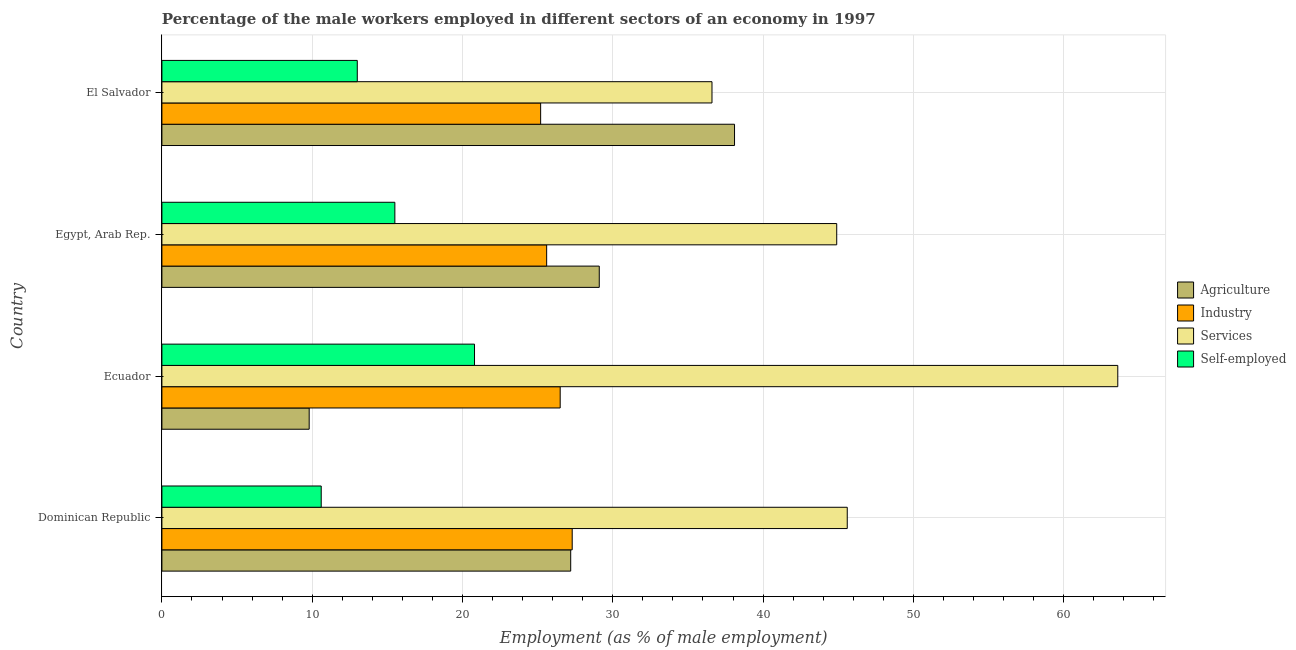How many groups of bars are there?
Provide a succinct answer. 4. Are the number of bars per tick equal to the number of legend labels?
Keep it short and to the point. Yes. Are the number of bars on each tick of the Y-axis equal?
Your answer should be compact. Yes. How many bars are there on the 4th tick from the top?
Ensure brevity in your answer.  4. How many bars are there on the 4th tick from the bottom?
Make the answer very short. 4. What is the label of the 1st group of bars from the top?
Give a very brief answer. El Salvador. What is the percentage of male workers in industry in Ecuador?
Keep it short and to the point. 26.5. Across all countries, what is the maximum percentage of male workers in services?
Offer a very short reply. 63.6. Across all countries, what is the minimum percentage of male workers in industry?
Your answer should be compact. 25.2. In which country was the percentage of male workers in services maximum?
Give a very brief answer. Ecuador. In which country was the percentage of male workers in agriculture minimum?
Ensure brevity in your answer.  Ecuador. What is the total percentage of male workers in agriculture in the graph?
Your answer should be very brief. 104.2. What is the difference between the percentage of male workers in agriculture in Dominican Republic and the percentage of male workers in industry in Egypt, Arab Rep.?
Your answer should be very brief. 1.6. What is the average percentage of self employed male workers per country?
Ensure brevity in your answer.  14.97. What is the difference between the percentage of male workers in agriculture and percentage of male workers in industry in Egypt, Arab Rep.?
Give a very brief answer. 3.5. What is the ratio of the percentage of self employed male workers in Ecuador to that in El Salvador?
Ensure brevity in your answer.  1.6. Is the percentage of male workers in agriculture in Dominican Republic less than that in Ecuador?
Offer a very short reply. No. Is the difference between the percentage of male workers in industry in Ecuador and El Salvador greater than the difference between the percentage of male workers in services in Ecuador and El Salvador?
Your response must be concise. No. What is the difference between the highest and the second highest percentage of male workers in agriculture?
Offer a terse response. 9. What is the difference between the highest and the lowest percentage of male workers in industry?
Make the answer very short. 2.1. Is it the case that in every country, the sum of the percentage of male workers in services and percentage of self employed male workers is greater than the sum of percentage of male workers in agriculture and percentage of male workers in industry?
Offer a terse response. No. What does the 2nd bar from the top in El Salvador represents?
Provide a short and direct response. Services. What does the 1st bar from the bottom in Ecuador represents?
Ensure brevity in your answer.  Agriculture. How many countries are there in the graph?
Offer a terse response. 4. What is the difference between two consecutive major ticks on the X-axis?
Your answer should be very brief. 10. How many legend labels are there?
Your answer should be compact. 4. How are the legend labels stacked?
Keep it short and to the point. Vertical. What is the title of the graph?
Your answer should be very brief. Percentage of the male workers employed in different sectors of an economy in 1997. Does "Gender equality" appear as one of the legend labels in the graph?
Your answer should be compact. No. What is the label or title of the X-axis?
Offer a very short reply. Employment (as % of male employment). What is the Employment (as % of male employment) in Agriculture in Dominican Republic?
Offer a terse response. 27.2. What is the Employment (as % of male employment) of Industry in Dominican Republic?
Provide a succinct answer. 27.3. What is the Employment (as % of male employment) in Services in Dominican Republic?
Ensure brevity in your answer.  45.6. What is the Employment (as % of male employment) in Self-employed in Dominican Republic?
Provide a succinct answer. 10.6. What is the Employment (as % of male employment) in Agriculture in Ecuador?
Keep it short and to the point. 9.8. What is the Employment (as % of male employment) of Industry in Ecuador?
Provide a short and direct response. 26.5. What is the Employment (as % of male employment) in Services in Ecuador?
Ensure brevity in your answer.  63.6. What is the Employment (as % of male employment) in Self-employed in Ecuador?
Offer a terse response. 20.8. What is the Employment (as % of male employment) of Agriculture in Egypt, Arab Rep.?
Provide a short and direct response. 29.1. What is the Employment (as % of male employment) of Industry in Egypt, Arab Rep.?
Your answer should be very brief. 25.6. What is the Employment (as % of male employment) in Services in Egypt, Arab Rep.?
Provide a succinct answer. 44.9. What is the Employment (as % of male employment) of Self-employed in Egypt, Arab Rep.?
Provide a succinct answer. 15.5. What is the Employment (as % of male employment) in Agriculture in El Salvador?
Your answer should be compact. 38.1. What is the Employment (as % of male employment) of Industry in El Salvador?
Your response must be concise. 25.2. What is the Employment (as % of male employment) in Services in El Salvador?
Make the answer very short. 36.6. Across all countries, what is the maximum Employment (as % of male employment) in Agriculture?
Offer a terse response. 38.1. Across all countries, what is the maximum Employment (as % of male employment) in Industry?
Your answer should be very brief. 27.3. Across all countries, what is the maximum Employment (as % of male employment) of Services?
Provide a succinct answer. 63.6. Across all countries, what is the maximum Employment (as % of male employment) of Self-employed?
Give a very brief answer. 20.8. Across all countries, what is the minimum Employment (as % of male employment) in Agriculture?
Offer a terse response. 9.8. Across all countries, what is the minimum Employment (as % of male employment) of Industry?
Make the answer very short. 25.2. Across all countries, what is the minimum Employment (as % of male employment) of Services?
Your response must be concise. 36.6. Across all countries, what is the minimum Employment (as % of male employment) in Self-employed?
Your answer should be very brief. 10.6. What is the total Employment (as % of male employment) in Agriculture in the graph?
Your response must be concise. 104.2. What is the total Employment (as % of male employment) in Industry in the graph?
Offer a very short reply. 104.6. What is the total Employment (as % of male employment) of Services in the graph?
Offer a terse response. 190.7. What is the total Employment (as % of male employment) in Self-employed in the graph?
Your response must be concise. 59.9. What is the difference between the Employment (as % of male employment) in Industry in Dominican Republic and that in Ecuador?
Ensure brevity in your answer.  0.8. What is the difference between the Employment (as % of male employment) in Self-employed in Dominican Republic and that in Ecuador?
Make the answer very short. -10.2. What is the difference between the Employment (as % of male employment) of Agriculture in Dominican Republic and that in Egypt, Arab Rep.?
Offer a terse response. -1.9. What is the difference between the Employment (as % of male employment) in Services in Dominican Republic and that in Egypt, Arab Rep.?
Offer a terse response. 0.7. What is the difference between the Employment (as % of male employment) of Self-employed in Dominican Republic and that in Egypt, Arab Rep.?
Your answer should be compact. -4.9. What is the difference between the Employment (as % of male employment) of Agriculture in Dominican Republic and that in El Salvador?
Keep it short and to the point. -10.9. What is the difference between the Employment (as % of male employment) of Industry in Dominican Republic and that in El Salvador?
Keep it short and to the point. 2.1. What is the difference between the Employment (as % of male employment) of Services in Dominican Republic and that in El Salvador?
Ensure brevity in your answer.  9. What is the difference between the Employment (as % of male employment) of Agriculture in Ecuador and that in Egypt, Arab Rep.?
Offer a very short reply. -19.3. What is the difference between the Employment (as % of male employment) of Services in Ecuador and that in Egypt, Arab Rep.?
Keep it short and to the point. 18.7. What is the difference between the Employment (as % of male employment) of Agriculture in Ecuador and that in El Salvador?
Your response must be concise. -28.3. What is the difference between the Employment (as % of male employment) of Industry in Ecuador and that in El Salvador?
Provide a succinct answer. 1.3. What is the difference between the Employment (as % of male employment) in Self-employed in Ecuador and that in El Salvador?
Offer a terse response. 7.8. What is the difference between the Employment (as % of male employment) of Agriculture in Egypt, Arab Rep. and that in El Salvador?
Keep it short and to the point. -9. What is the difference between the Employment (as % of male employment) of Services in Egypt, Arab Rep. and that in El Salvador?
Make the answer very short. 8.3. What is the difference between the Employment (as % of male employment) in Self-employed in Egypt, Arab Rep. and that in El Salvador?
Ensure brevity in your answer.  2.5. What is the difference between the Employment (as % of male employment) of Agriculture in Dominican Republic and the Employment (as % of male employment) of Services in Ecuador?
Ensure brevity in your answer.  -36.4. What is the difference between the Employment (as % of male employment) of Industry in Dominican Republic and the Employment (as % of male employment) of Services in Ecuador?
Your response must be concise. -36.3. What is the difference between the Employment (as % of male employment) in Services in Dominican Republic and the Employment (as % of male employment) in Self-employed in Ecuador?
Your response must be concise. 24.8. What is the difference between the Employment (as % of male employment) of Agriculture in Dominican Republic and the Employment (as % of male employment) of Services in Egypt, Arab Rep.?
Your response must be concise. -17.7. What is the difference between the Employment (as % of male employment) of Industry in Dominican Republic and the Employment (as % of male employment) of Services in Egypt, Arab Rep.?
Keep it short and to the point. -17.6. What is the difference between the Employment (as % of male employment) of Services in Dominican Republic and the Employment (as % of male employment) of Self-employed in Egypt, Arab Rep.?
Make the answer very short. 30.1. What is the difference between the Employment (as % of male employment) of Agriculture in Dominican Republic and the Employment (as % of male employment) of Services in El Salvador?
Offer a terse response. -9.4. What is the difference between the Employment (as % of male employment) in Agriculture in Dominican Republic and the Employment (as % of male employment) in Self-employed in El Salvador?
Make the answer very short. 14.2. What is the difference between the Employment (as % of male employment) in Services in Dominican Republic and the Employment (as % of male employment) in Self-employed in El Salvador?
Offer a terse response. 32.6. What is the difference between the Employment (as % of male employment) of Agriculture in Ecuador and the Employment (as % of male employment) of Industry in Egypt, Arab Rep.?
Your answer should be very brief. -15.8. What is the difference between the Employment (as % of male employment) of Agriculture in Ecuador and the Employment (as % of male employment) of Services in Egypt, Arab Rep.?
Keep it short and to the point. -35.1. What is the difference between the Employment (as % of male employment) of Agriculture in Ecuador and the Employment (as % of male employment) of Self-employed in Egypt, Arab Rep.?
Ensure brevity in your answer.  -5.7. What is the difference between the Employment (as % of male employment) of Industry in Ecuador and the Employment (as % of male employment) of Services in Egypt, Arab Rep.?
Your answer should be compact. -18.4. What is the difference between the Employment (as % of male employment) in Industry in Ecuador and the Employment (as % of male employment) in Self-employed in Egypt, Arab Rep.?
Your answer should be very brief. 11. What is the difference between the Employment (as % of male employment) of Services in Ecuador and the Employment (as % of male employment) of Self-employed in Egypt, Arab Rep.?
Your answer should be compact. 48.1. What is the difference between the Employment (as % of male employment) of Agriculture in Ecuador and the Employment (as % of male employment) of Industry in El Salvador?
Keep it short and to the point. -15.4. What is the difference between the Employment (as % of male employment) of Agriculture in Ecuador and the Employment (as % of male employment) of Services in El Salvador?
Give a very brief answer. -26.8. What is the difference between the Employment (as % of male employment) of Industry in Ecuador and the Employment (as % of male employment) of Services in El Salvador?
Your answer should be very brief. -10.1. What is the difference between the Employment (as % of male employment) of Services in Ecuador and the Employment (as % of male employment) of Self-employed in El Salvador?
Give a very brief answer. 50.6. What is the difference between the Employment (as % of male employment) of Agriculture in Egypt, Arab Rep. and the Employment (as % of male employment) of Services in El Salvador?
Ensure brevity in your answer.  -7.5. What is the difference between the Employment (as % of male employment) in Agriculture in Egypt, Arab Rep. and the Employment (as % of male employment) in Self-employed in El Salvador?
Make the answer very short. 16.1. What is the difference between the Employment (as % of male employment) of Industry in Egypt, Arab Rep. and the Employment (as % of male employment) of Services in El Salvador?
Keep it short and to the point. -11. What is the difference between the Employment (as % of male employment) of Industry in Egypt, Arab Rep. and the Employment (as % of male employment) of Self-employed in El Salvador?
Your response must be concise. 12.6. What is the difference between the Employment (as % of male employment) in Services in Egypt, Arab Rep. and the Employment (as % of male employment) in Self-employed in El Salvador?
Your answer should be very brief. 31.9. What is the average Employment (as % of male employment) of Agriculture per country?
Offer a terse response. 26.05. What is the average Employment (as % of male employment) in Industry per country?
Ensure brevity in your answer.  26.15. What is the average Employment (as % of male employment) in Services per country?
Your answer should be compact. 47.67. What is the average Employment (as % of male employment) of Self-employed per country?
Offer a very short reply. 14.97. What is the difference between the Employment (as % of male employment) in Agriculture and Employment (as % of male employment) in Services in Dominican Republic?
Your answer should be compact. -18.4. What is the difference between the Employment (as % of male employment) in Industry and Employment (as % of male employment) in Services in Dominican Republic?
Your answer should be compact. -18.3. What is the difference between the Employment (as % of male employment) of Industry and Employment (as % of male employment) of Self-employed in Dominican Republic?
Ensure brevity in your answer.  16.7. What is the difference between the Employment (as % of male employment) in Agriculture and Employment (as % of male employment) in Industry in Ecuador?
Your answer should be compact. -16.7. What is the difference between the Employment (as % of male employment) of Agriculture and Employment (as % of male employment) of Services in Ecuador?
Give a very brief answer. -53.8. What is the difference between the Employment (as % of male employment) of Industry and Employment (as % of male employment) of Services in Ecuador?
Give a very brief answer. -37.1. What is the difference between the Employment (as % of male employment) in Services and Employment (as % of male employment) in Self-employed in Ecuador?
Your response must be concise. 42.8. What is the difference between the Employment (as % of male employment) in Agriculture and Employment (as % of male employment) in Services in Egypt, Arab Rep.?
Offer a terse response. -15.8. What is the difference between the Employment (as % of male employment) in Industry and Employment (as % of male employment) in Services in Egypt, Arab Rep.?
Provide a succinct answer. -19.3. What is the difference between the Employment (as % of male employment) in Industry and Employment (as % of male employment) in Self-employed in Egypt, Arab Rep.?
Offer a very short reply. 10.1. What is the difference between the Employment (as % of male employment) in Services and Employment (as % of male employment) in Self-employed in Egypt, Arab Rep.?
Your response must be concise. 29.4. What is the difference between the Employment (as % of male employment) of Agriculture and Employment (as % of male employment) of Services in El Salvador?
Offer a very short reply. 1.5. What is the difference between the Employment (as % of male employment) of Agriculture and Employment (as % of male employment) of Self-employed in El Salvador?
Provide a short and direct response. 25.1. What is the difference between the Employment (as % of male employment) of Industry and Employment (as % of male employment) of Services in El Salvador?
Your answer should be very brief. -11.4. What is the difference between the Employment (as % of male employment) of Industry and Employment (as % of male employment) of Self-employed in El Salvador?
Provide a short and direct response. 12.2. What is the difference between the Employment (as % of male employment) in Services and Employment (as % of male employment) in Self-employed in El Salvador?
Your response must be concise. 23.6. What is the ratio of the Employment (as % of male employment) in Agriculture in Dominican Republic to that in Ecuador?
Give a very brief answer. 2.78. What is the ratio of the Employment (as % of male employment) of Industry in Dominican Republic to that in Ecuador?
Provide a short and direct response. 1.03. What is the ratio of the Employment (as % of male employment) of Services in Dominican Republic to that in Ecuador?
Provide a short and direct response. 0.72. What is the ratio of the Employment (as % of male employment) in Self-employed in Dominican Republic to that in Ecuador?
Your answer should be compact. 0.51. What is the ratio of the Employment (as % of male employment) in Agriculture in Dominican Republic to that in Egypt, Arab Rep.?
Offer a terse response. 0.93. What is the ratio of the Employment (as % of male employment) of Industry in Dominican Republic to that in Egypt, Arab Rep.?
Ensure brevity in your answer.  1.07. What is the ratio of the Employment (as % of male employment) in Services in Dominican Republic to that in Egypt, Arab Rep.?
Make the answer very short. 1.02. What is the ratio of the Employment (as % of male employment) in Self-employed in Dominican Republic to that in Egypt, Arab Rep.?
Provide a short and direct response. 0.68. What is the ratio of the Employment (as % of male employment) in Agriculture in Dominican Republic to that in El Salvador?
Keep it short and to the point. 0.71. What is the ratio of the Employment (as % of male employment) in Industry in Dominican Republic to that in El Salvador?
Provide a succinct answer. 1.08. What is the ratio of the Employment (as % of male employment) of Services in Dominican Republic to that in El Salvador?
Give a very brief answer. 1.25. What is the ratio of the Employment (as % of male employment) of Self-employed in Dominican Republic to that in El Salvador?
Your answer should be very brief. 0.82. What is the ratio of the Employment (as % of male employment) of Agriculture in Ecuador to that in Egypt, Arab Rep.?
Provide a short and direct response. 0.34. What is the ratio of the Employment (as % of male employment) of Industry in Ecuador to that in Egypt, Arab Rep.?
Provide a succinct answer. 1.04. What is the ratio of the Employment (as % of male employment) of Services in Ecuador to that in Egypt, Arab Rep.?
Provide a short and direct response. 1.42. What is the ratio of the Employment (as % of male employment) of Self-employed in Ecuador to that in Egypt, Arab Rep.?
Provide a short and direct response. 1.34. What is the ratio of the Employment (as % of male employment) of Agriculture in Ecuador to that in El Salvador?
Keep it short and to the point. 0.26. What is the ratio of the Employment (as % of male employment) in Industry in Ecuador to that in El Salvador?
Give a very brief answer. 1.05. What is the ratio of the Employment (as % of male employment) of Services in Ecuador to that in El Salvador?
Keep it short and to the point. 1.74. What is the ratio of the Employment (as % of male employment) in Agriculture in Egypt, Arab Rep. to that in El Salvador?
Your response must be concise. 0.76. What is the ratio of the Employment (as % of male employment) in Industry in Egypt, Arab Rep. to that in El Salvador?
Provide a short and direct response. 1.02. What is the ratio of the Employment (as % of male employment) of Services in Egypt, Arab Rep. to that in El Salvador?
Your answer should be compact. 1.23. What is the ratio of the Employment (as % of male employment) in Self-employed in Egypt, Arab Rep. to that in El Salvador?
Ensure brevity in your answer.  1.19. What is the difference between the highest and the second highest Employment (as % of male employment) in Agriculture?
Your answer should be very brief. 9. What is the difference between the highest and the second highest Employment (as % of male employment) of Services?
Keep it short and to the point. 18. What is the difference between the highest and the lowest Employment (as % of male employment) in Agriculture?
Keep it short and to the point. 28.3. What is the difference between the highest and the lowest Employment (as % of male employment) of Industry?
Give a very brief answer. 2.1. What is the difference between the highest and the lowest Employment (as % of male employment) in Self-employed?
Offer a very short reply. 10.2. 